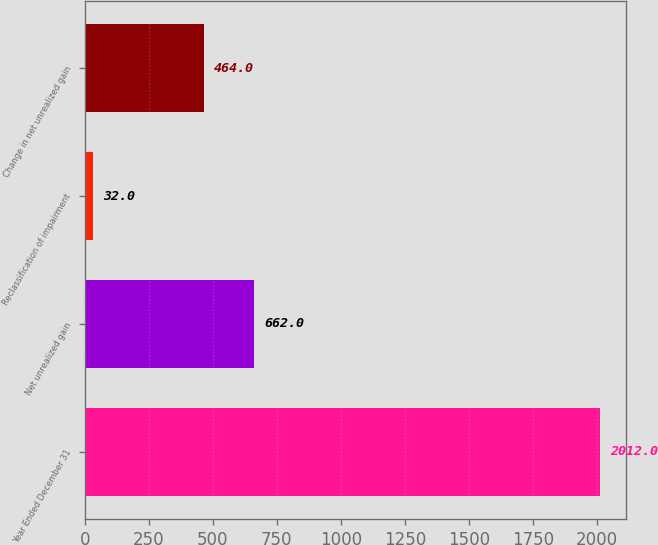<chart> <loc_0><loc_0><loc_500><loc_500><bar_chart><fcel>Year Ended December 31<fcel>Net unrealized gain<fcel>Reclassification of impairment<fcel>Change in net unrealized gain<nl><fcel>2012<fcel>662<fcel>32<fcel>464<nl></chart> 